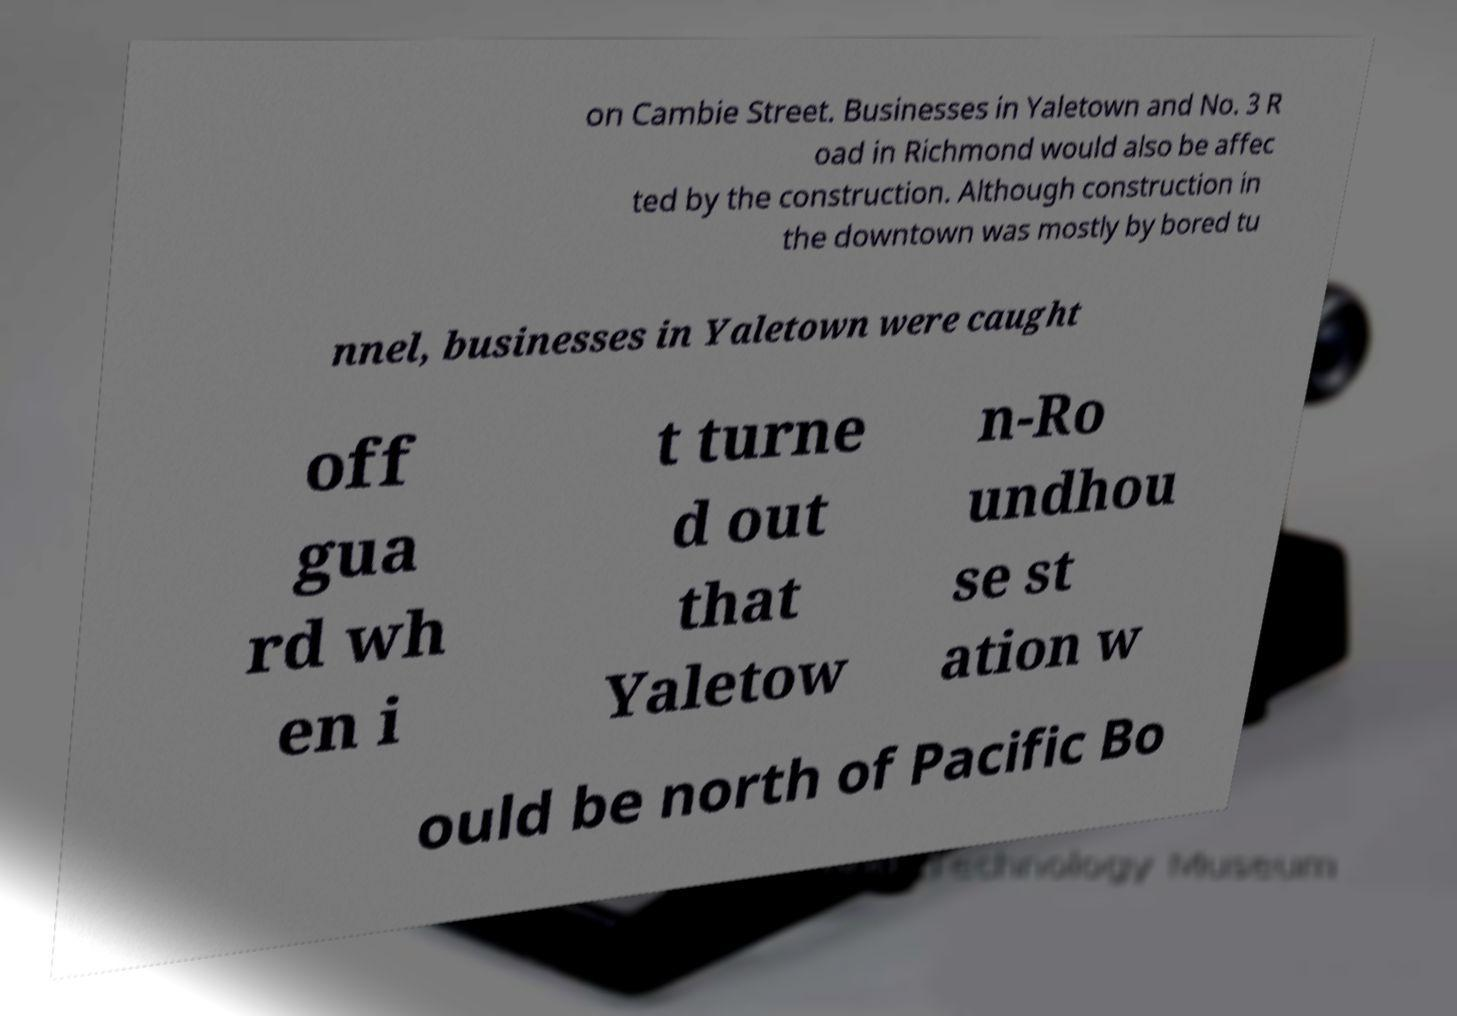What messages or text are displayed in this image? I need them in a readable, typed format. on Cambie Street. Businesses in Yaletown and No. 3 R oad in Richmond would also be affec ted by the construction. Although construction in the downtown was mostly by bored tu nnel, businesses in Yaletown were caught off gua rd wh en i t turne d out that Yaletow n-Ro undhou se st ation w ould be north of Pacific Bo 